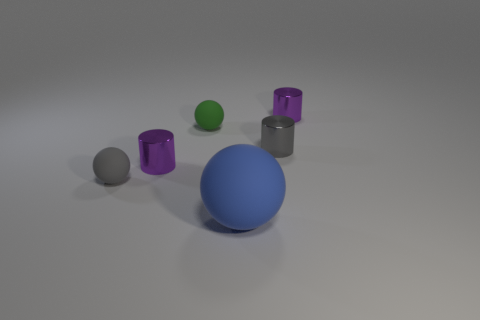Subtract all tiny purple metallic cylinders. How many cylinders are left? 1 Add 2 tiny balls. How many objects exist? 8 Subtract all gray balls. How many balls are left? 2 Subtract all blue cubes. How many purple cylinders are left? 2 Subtract 3 spheres. How many spheres are left? 0 Subtract all red cylinders. Subtract all cyan balls. How many cylinders are left? 3 Subtract all blue things. Subtract all tiny purple metal things. How many objects are left? 3 Add 2 small green matte spheres. How many small green matte spheres are left? 3 Add 6 large brown metal objects. How many large brown metal objects exist? 6 Subtract 1 purple cylinders. How many objects are left? 5 